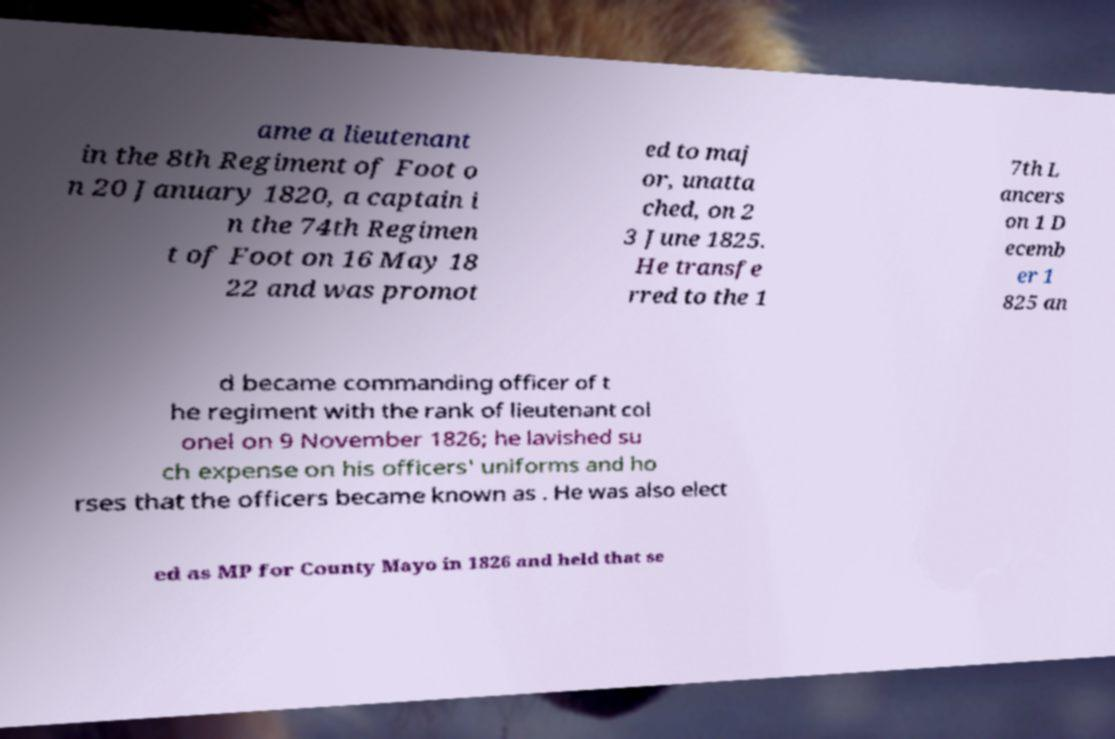For documentation purposes, I need the text within this image transcribed. Could you provide that? ame a lieutenant in the 8th Regiment of Foot o n 20 January 1820, a captain i n the 74th Regimen t of Foot on 16 May 18 22 and was promot ed to maj or, unatta ched, on 2 3 June 1825. He transfe rred to the 1 7th L ancers on 1 D ecemb er 1 825 an d became commanding officer of t he regiment with the rank of lieutenant col onel on 9 November 1826; he lavished su ch expense on his officers' uniforms and ho rses that the officers became known as . He was also elect ed as MP for County Mayo in 1826 and held that se 